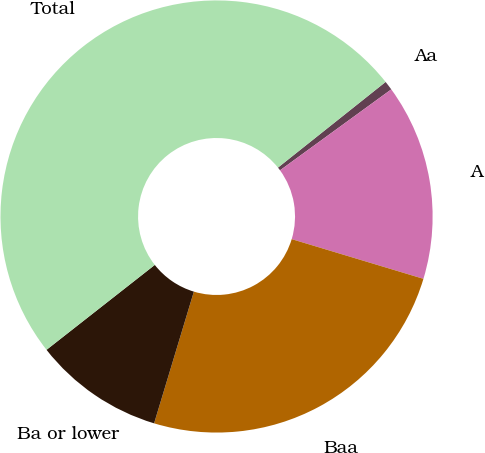<chart> <loc_0><loc_0><loc_500><loc_500><pie_chart><fcel>Aa<fcel>A<fcel>Baa<fcel>Ba or lower<fcel>Total<nl><fcel>0.69%<fcel>14.67%<fcel>25.01%<fcel>9.75%<fcel>49.89%<nl></chart> 